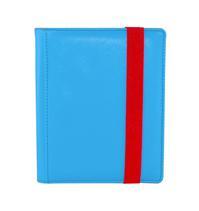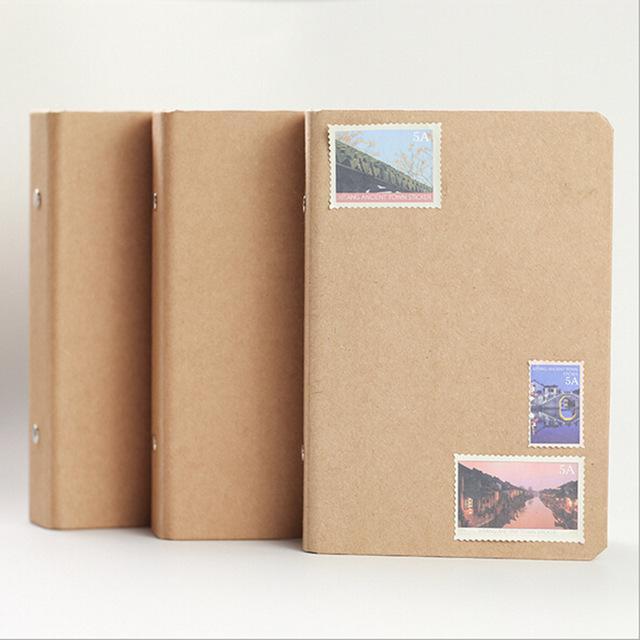The first image is the image on the left, the second image is the image on the right. For the images shown, is this caption "A set of three tan notebooks is arranged in a standing position." true? Answer yes or no. Yes. 